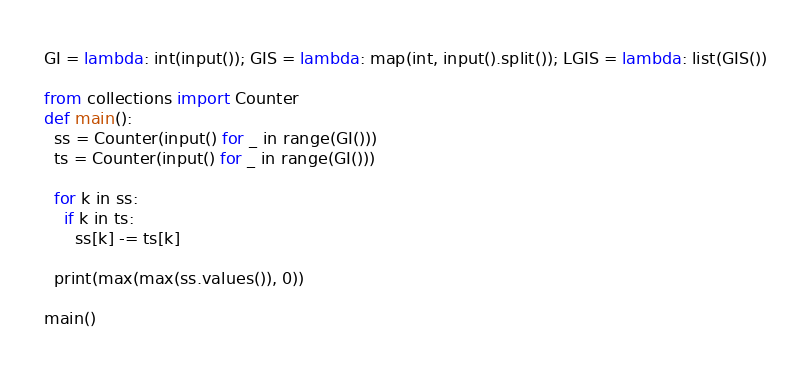<code> <loc_0><loc_0><loc_500><loc_500><_Python_>GI = lambda: int(input()); GIS = lambda: map(int, input().split()); LGIS = lambda: list(GIS())

from collections import Counter
def main():
  ss = Counter(input() for _ in range(GI()))
  ts = Counter(input() for _ in range(GI()))

  for k in ss:
    if k in ts:
      ss[k] -= ts[k]

  print(max(max(ss.values()), 0))

main()</code> 